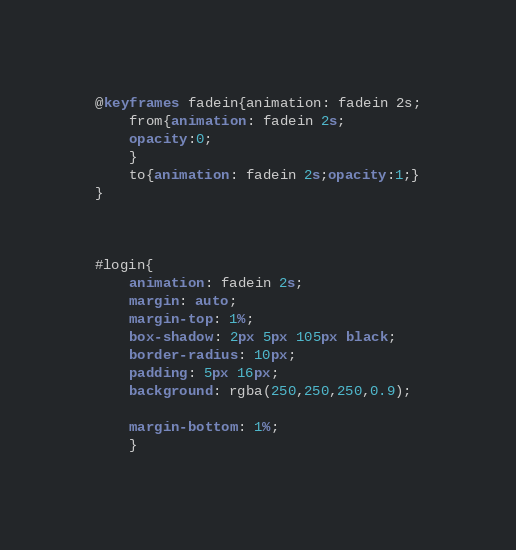<code> <loc_0><loc_0><loc_500><loc_500><_CSS_>@keyframes fadein{animation: fadein 2s;
    from{animation: fadein 2s;
    opacity:0;
    }
    to{animation: fadein 2s;opacity:1;}
}



#login{
	animation: fadein 2s;
	margin: auto;
	margin-top: 1%;
	box-shadow: 2px 5px 105px black;
	border-radius: 10px;
	padding: 5px 16px;
	background: rgba(250,250,250,0.9);

	margin-bottom: 1%;
	}
</code> 